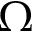<formula> <loc_0><loc_0><loc_500><loc_500>\Omega</formula> 